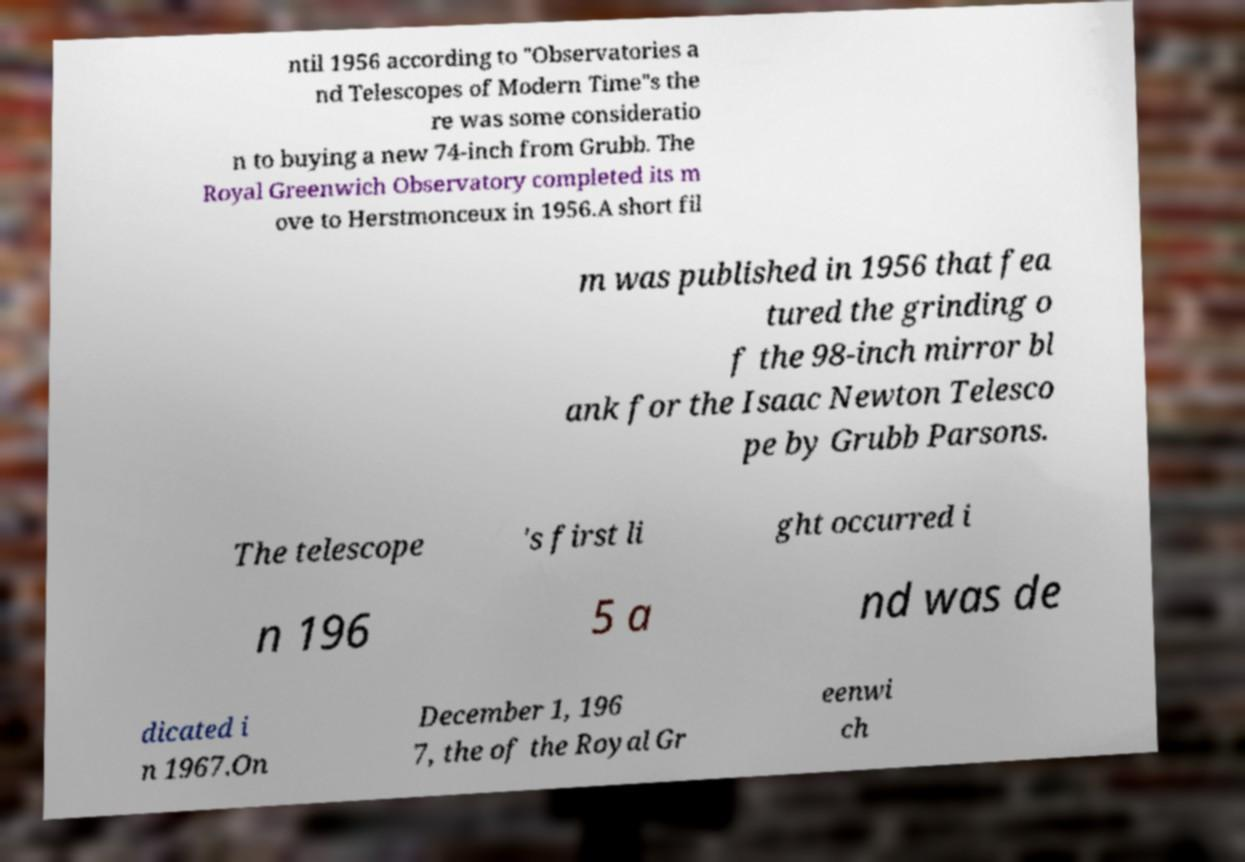I need the written content from this picture converted into text. Can you do that? ntil 1956 according to "Observatories a nd Telescopes of Modern Time"s the re was some consideratio n to buying a new 74-inch from Grubb. The Royal Greenwich Observatory completed its m ove to Herstmonceux in 1956.A short fil m was published in 1956 that fea tured the grinding o f the 98-inch mirror bl ank for the Isaac Newton Telesco pe by Grubb Parsons. The telescope 's first li ght occurred i n 196 5 a nd was de dicated i n 1967.On December 1, 196 7, the of the Royal Gr eenwi ch 